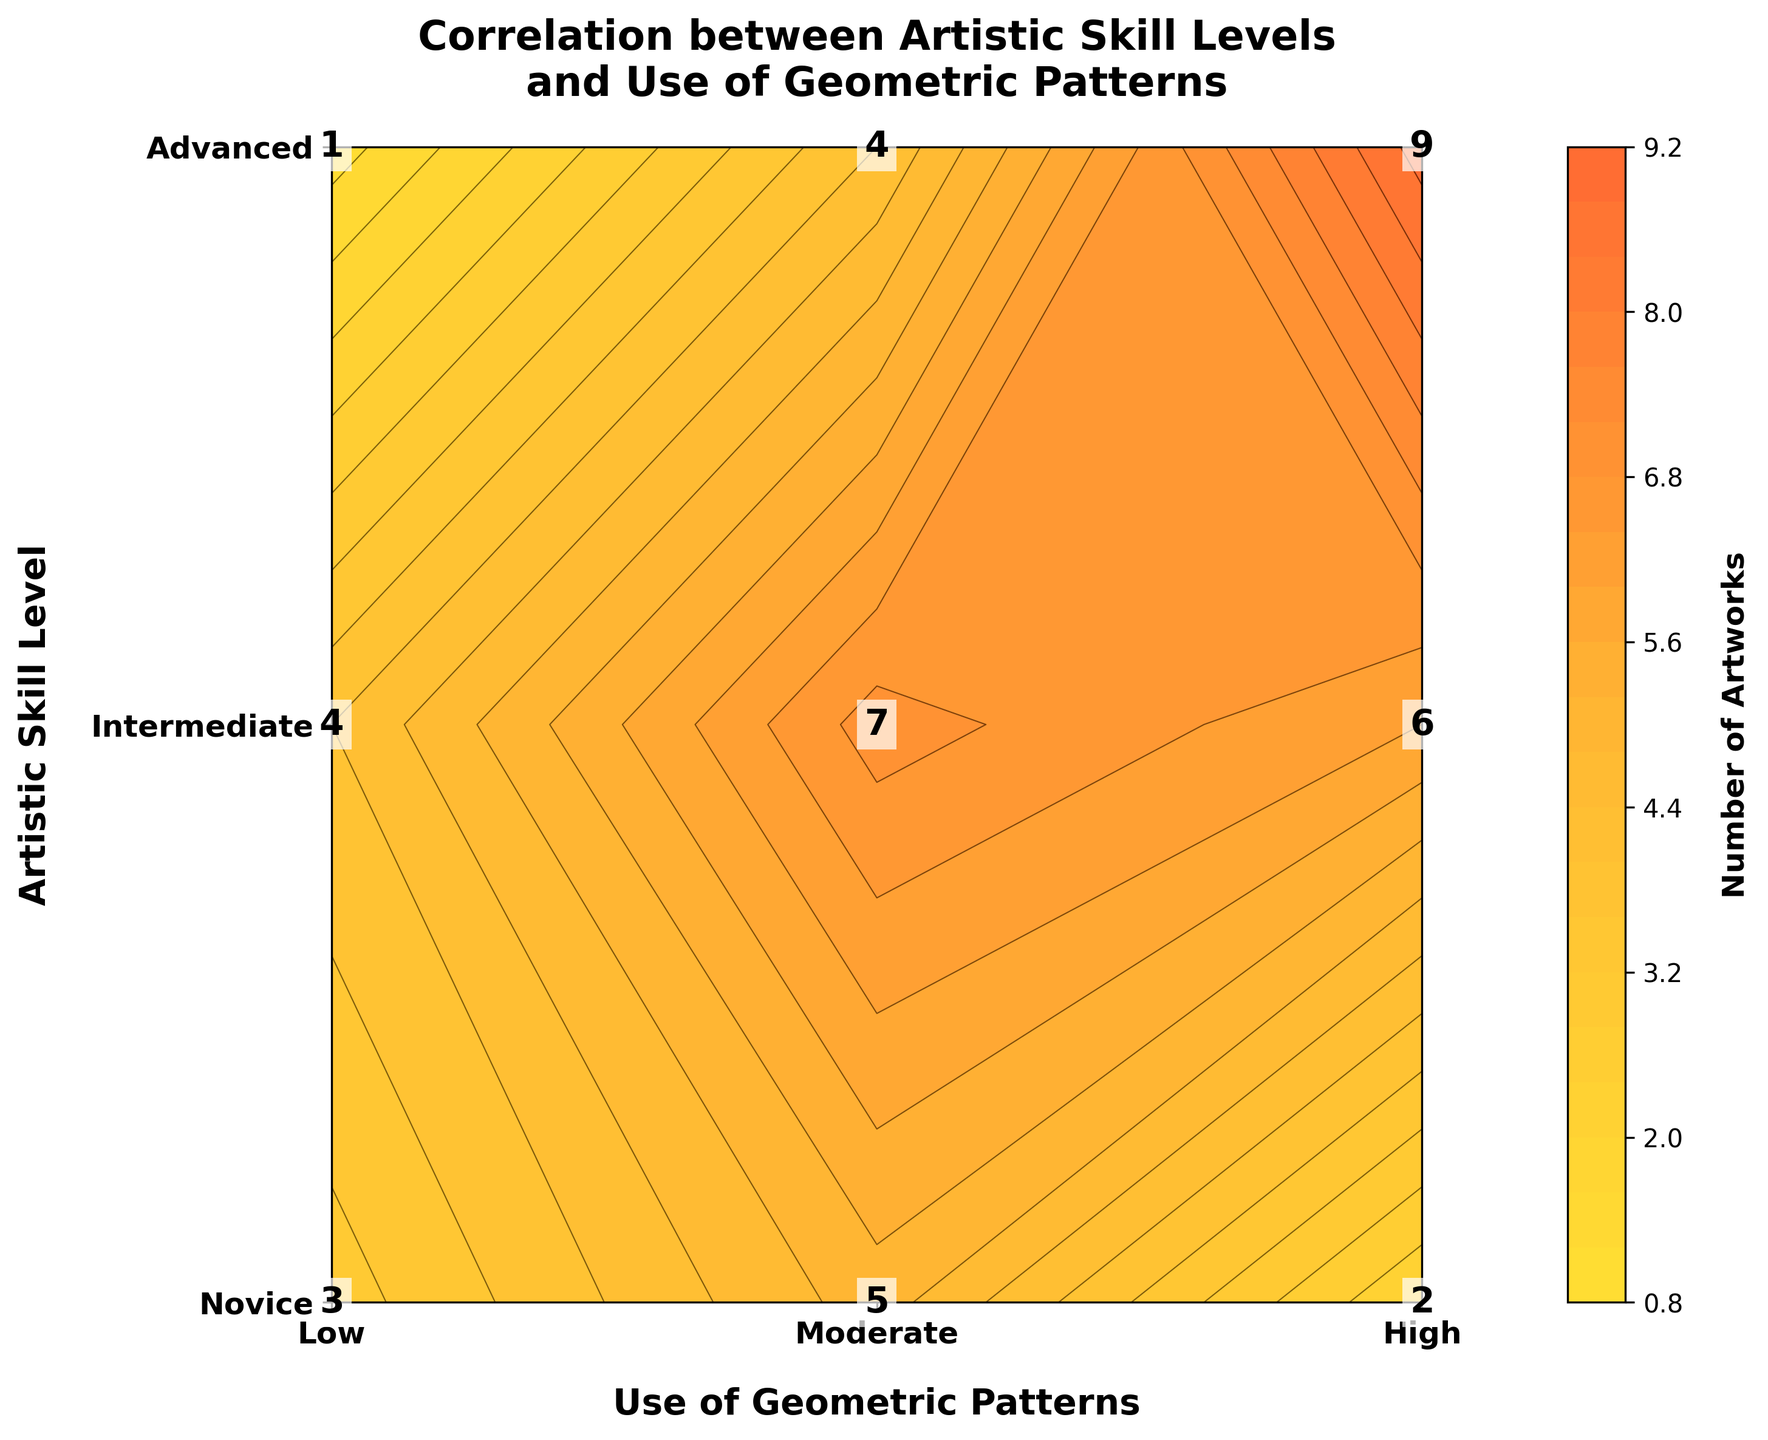What is the title of the plot? The title is usually displayed at the top of the plot in larger, bold font for easy identification. In this case, it should directly specify what the plot is about.
Answer: Correlation between Artistic Skill Levels and Use of Geometric Patterns What are the labels on the x-axis and y-axis? Labels help in understanding what each axis represents. Here, they relate to the skill levels and use of geometric patterns.
Answer: Use of Geometric Patterns (x-axis) and Artistic Skill Level (y-axis) Which skill level has the highest number of artworks with high use of geometric patterns? Look at the color intensity and the text annotations in the top row (representing the 'High' use of geometric patterns). Find the maximum value.
Answer: Advanced What is the number of artworks created by intermediate artists with moderate use of geometric patterns? In the middle row corresponding to intermediate skill level and the middle column for moderate use, check the text annotation.
Answer: 7 Is the number of artworks by advanced artists with low use of geometric patterns less than the number of artworks by novice artists with moderate use? Compare the values in the 'Advanced' row (low usage) and 'Novice' row (moderate usage).
Answer: Yes What is the total number of artworks created by novice artists? Sum the numbers in the 'Novice' row: 3 (Low) + 5 (Moderate) + 2 (High).
Answer: 10 Which combination of skill level and geometric pattern usage has the lowest number of artworks? Identify the cell with the minimum value by looking at the text annotations and or the color shading across the entire plot.
Answer: Advanced with Low use of geometric patterns How does the number of artworks created by intermediate artists with high use of geometric patterns compare to those created by novice artists with moderate use of geometric patterns? Compare the value in the middle row and last column with the value in the top row and middle column.
Answer: Intermediate (High) is greater What is the color range used to represent the number of artworks? Observe the gradient of colors in the color bar beside the plot which represents the range from minimum to maximum number of artworks.
Answer: Gold to Orange to Red Which usage pattern (Low, Moderate, High) shows the most variation in the number of artworks across all skill levels? Calculate the range (maximum - minimum) for each usage pattern across all skill levels and identify the largest range.
Answer: High Use of Geometric Patterns 